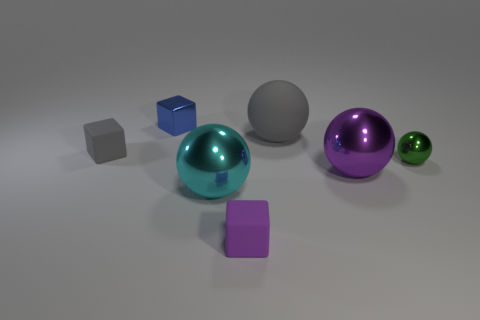Is the color of the tiny rubber block in front of the big purple shiny ball the same as the small metal block?
Provide a succinct answer. No. What is the shape of the small thing that is behind the tiny matte cube left of the rubber block in front of the tiny sphere?
Your answer should be compact. Cube. There is a large metal sphere that is left of the big matte ball; how many cyan things are left of it?
Keep it short and to the point. 0. Is the small gray thing made of the same material as the large purple thing?
Give a very brief answer. No. There is a small thing left of the shiny thing that is behind the green ball; what number of balls are in front of it?
Offer a terse response. 3. What color is the sphere on the left side of the large gray matte thing?
Provide a short and direct response. Cyan. The matte thing behind the small matte object behind the cyan thing is what shape?
Your answer should be very brief. Sphere. Do the tiny metal block and the tiny sphere have the same color?
Offer a very short reply. No. What number of balls are purple objects or small gray objects?
Provide a succinct answer. 1. There is a ball that is both behind the purple metal thing and left of the green thing; what material is it?
Offer a terse response. Rubber. 